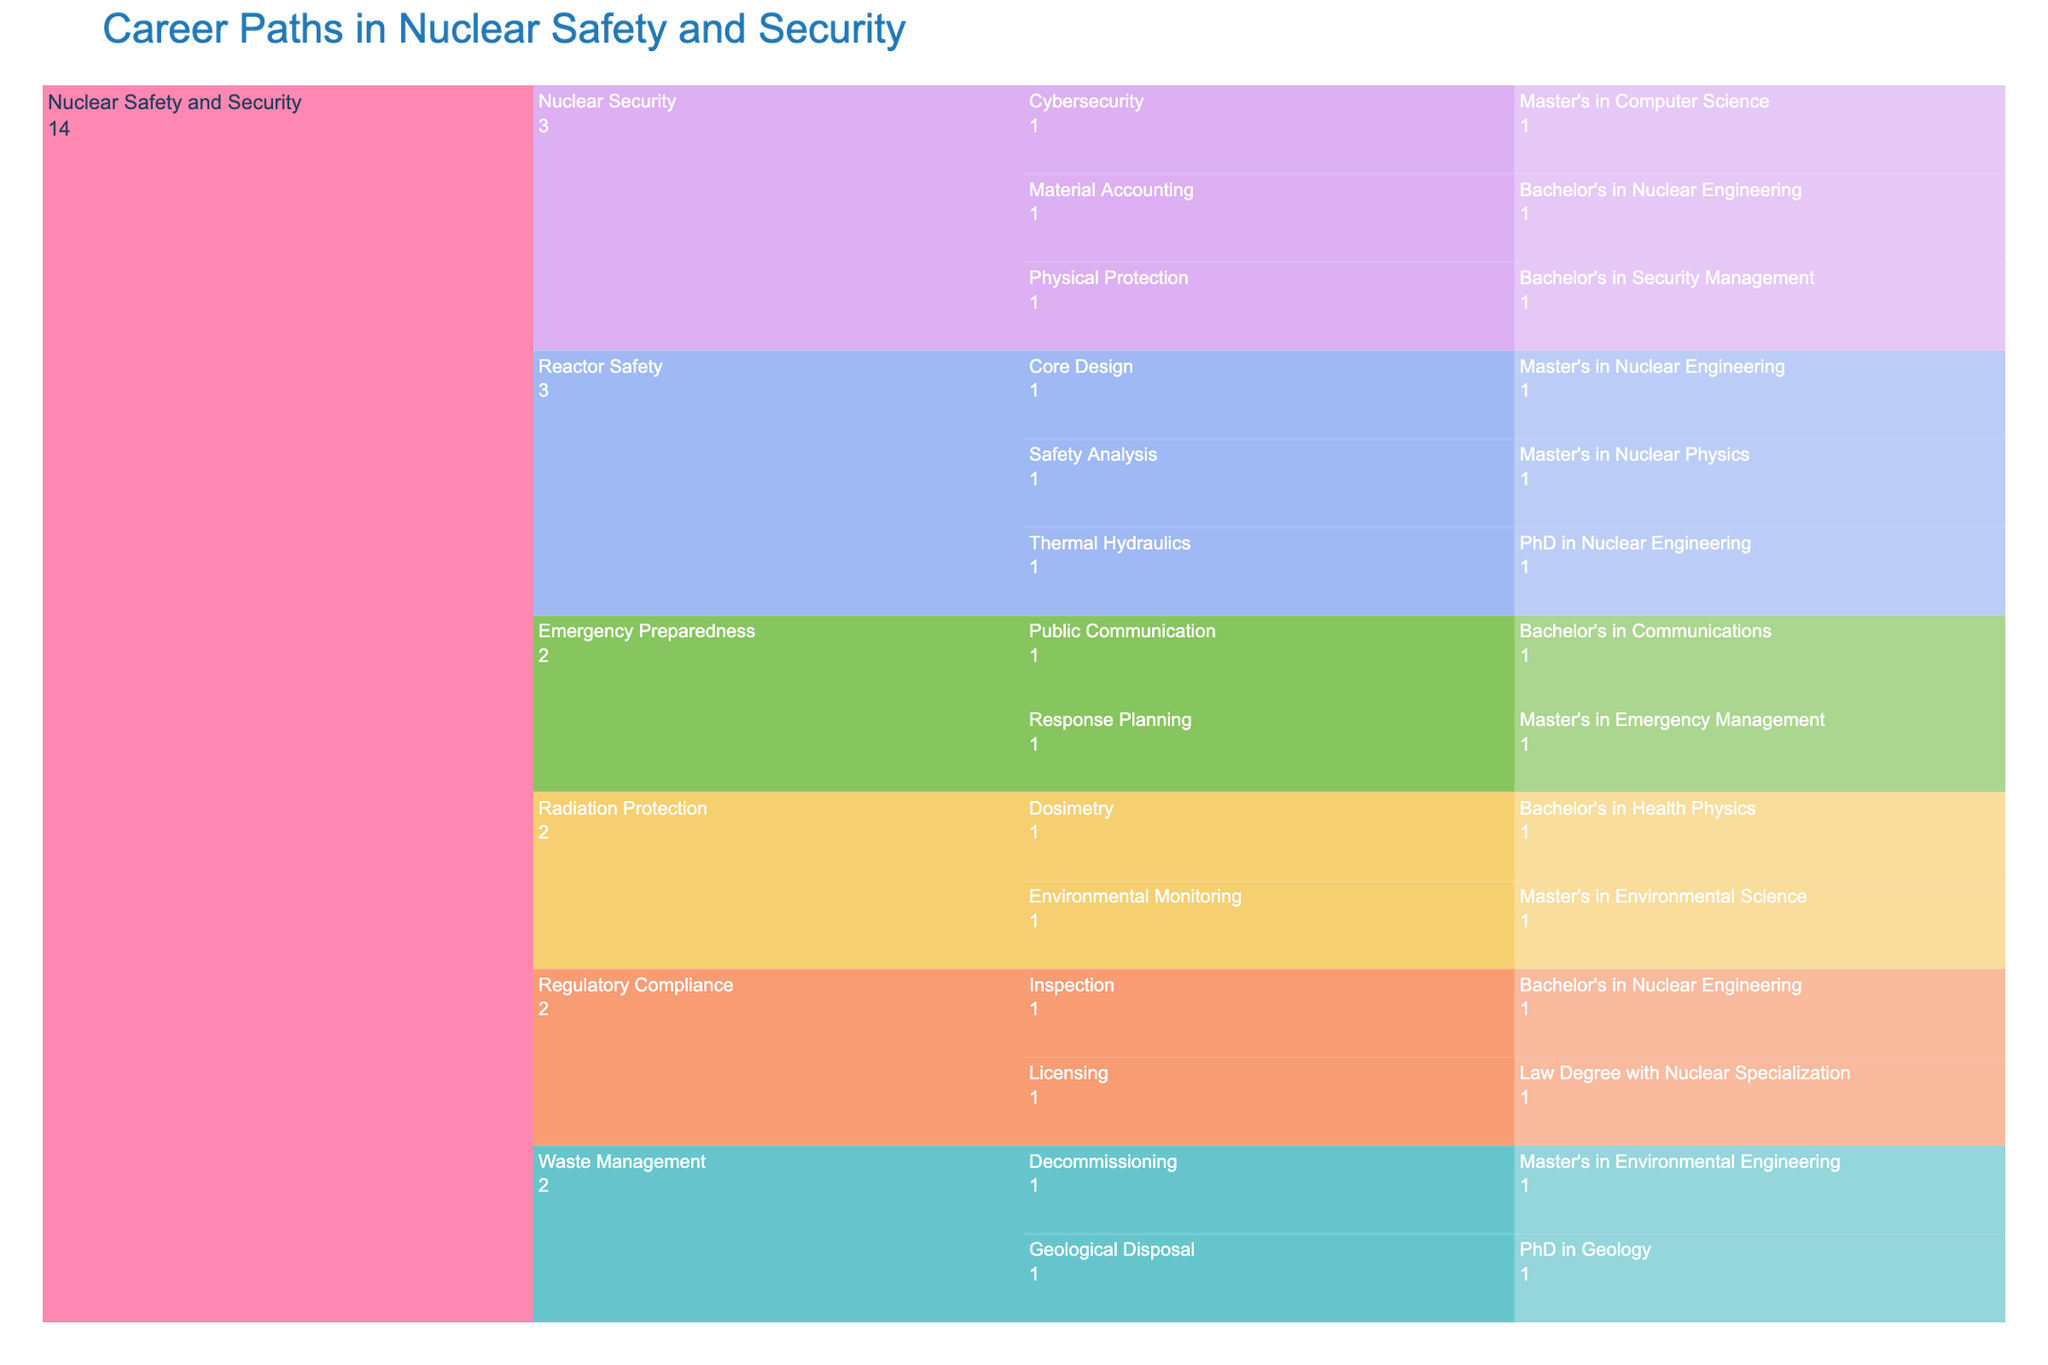What is the title of the chart? The title is usually placed at the top of the chart and is prominently displayed to provide context. In this case, it's clear from the code that generates the figure.
Answer: Career Paths in Nuclear Safety and Security Which specialization requires a PhD in Geology? We look at the specialization branches in the chart. Under Waste Management, we find Geological Disposal which requires a PhD in Geology.
Answer: Waste Management How many specializations are there under Nuclear Safety and Security? By examining the chart from the top level, you can count each specialization branch under Nuclear Safety and Security. These branches are Reactor Safety, Radiation Protection, Nuclear Security, Emergency Preparedness, Regulatory Compliance, and Waste Management, making a total of 6.
Answer: 6 Which sub-specialization falls under the specialization of Emergency Preparedness? In the chart, under the Emergency Preparedness specialization branch, the sub-specializations are Response Planning and Public Communication.
Answer: Response Planning and Public Communication What qualification is needed for the specialization of Cybersecurity? By looking at the sub-specialization branch under Nuclear Security, we find Cybersecurity, which requires a Master's in Computer Science.
Answer: Master's in Computer Science Which specialization has a sub-specialization that requires a Bachelor's in Communications? Looking through the chart, we see under the Emergency Preparedness branch, the Public Communication sub-specialization requires a Bachelor's in Communications.
Answer: Emergency Preparedness What is the qualification required for Safety Analysis in Reactor Safety? Navigating through the chart from Reactor Safety to Safety Analysis, we can see that it requires a Master's in Nuclear Physics.
Answer: Master's in Nuclear Physics Which specializations have their qualifications listed as a Bachelor's degree? From the chart, we can see that Radiation Protection (Dosimetry), Nuclear Security (Physical Protection, Material Accounting), Emergency Preparedness (Public Communication), and Regulatory Compliance (Inspection) have qualifications listed as a Bachelor's degree.
Answer: Radiation Protection, Nuclear Security, Emergency Preparedness, Regulatory Compliance In terms of qualifications, which specialization under Nuclear Security has the most diverse requirements? By examining the chart under Nuclear Security, the sub-specializations Physical Protection (Bachelor's in Security Management), Cybersecurity (Master's in Computer Science), and Material Accounting (Bachelor's in Nuclear Engineering) show a variety of degrees required, including both Bachelor's and Master's degrees.
Answer: Nuclear Security 